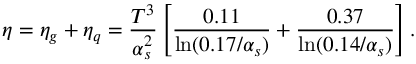<formula> <loc_0><loc_0><loc_500><loc_500>\eta = \eta _ { g } + \eta _ { q } = { \frac { T ^ { 3 } } { \alpha _ { s } ^ { 2 } } } \left [ { \frac { 0 . 1 1 } { \ln ( 0 . 1 7 / \alpha _ { s } ) } } + { \frac { 0 . 3 7 } { \ln ( 0 . 1 4 / \alpha _ { s } ) } } \right ] .</formula> 